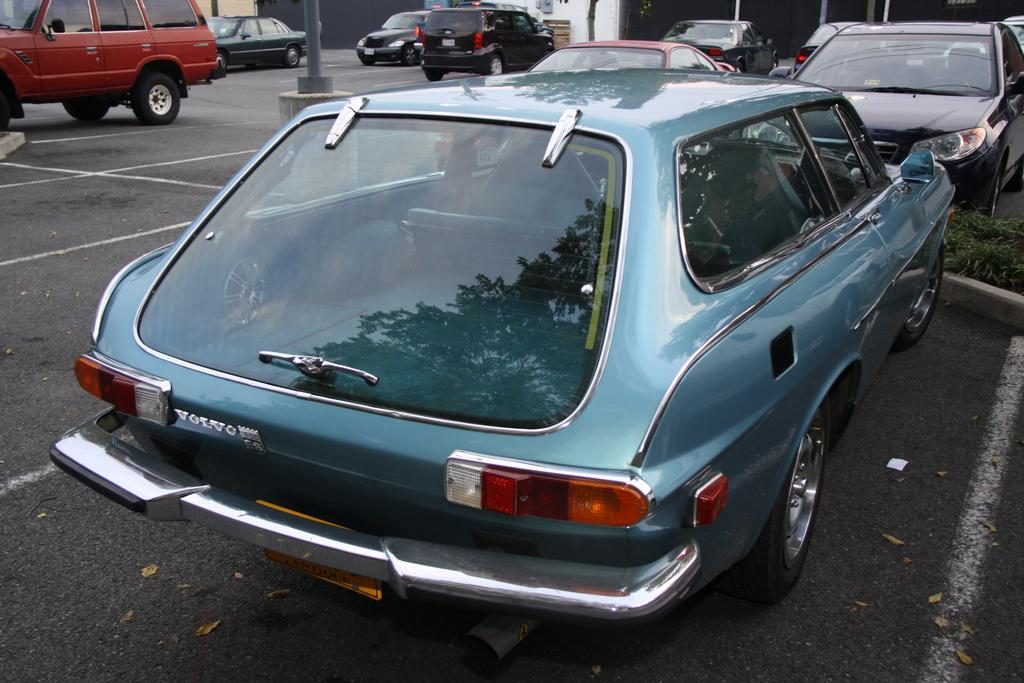What type of area is visible in the image? There is a parking area in the image. What can be seen in the parking area? Cars are parked in the parking area. What type of leather is used to make the badges on the cars in the image? There is no mention of badges or leather in the image, as it only shows a parking area with cars parked in it. 